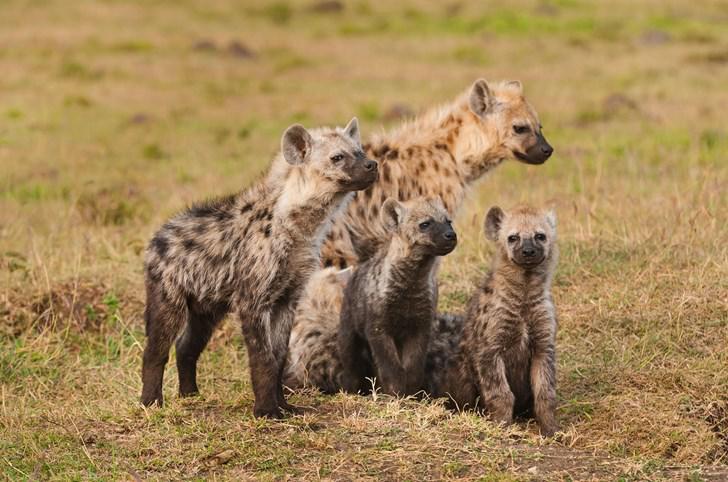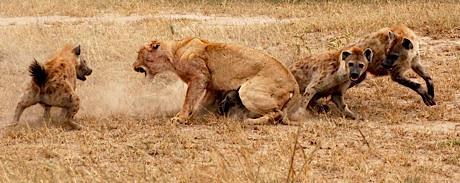The first image is the image on the left, the second image is the image on the right. Given the left and right images, does the statement "There are two hyenas." hold true? Answer yes or no. No. The first image is the image on the left, the second image is the image on the right. Analyze the images presented: Is the assertion "One image shows a single hyena moving forward and slightly to the left, and the other image includes a hyena with a wide-open fang-baring mouth and its body facing forward." valid? Answer yes or no. No. 